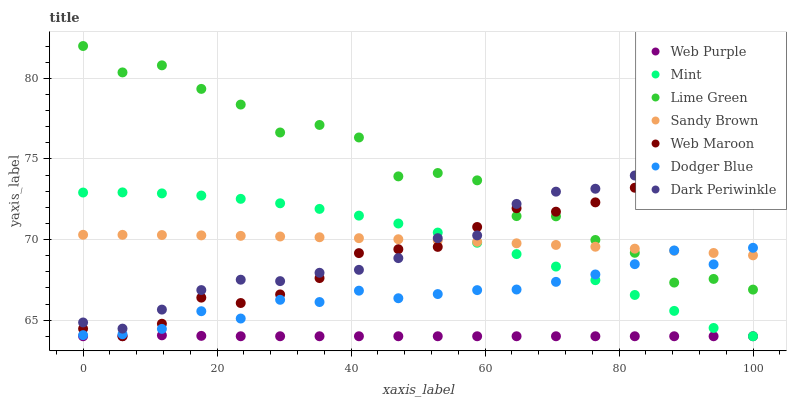Does Web Purple have the minimum area under the curve?
Answer yes or no. Yes. Does Lime Green have the maximum area under the curve?
Answer yes or no. Yes. Does Mint have the minimum area under the curve?
Answer yes or no. No. Does Mint have the maximum area under the curve?
Answer yes or no. No. Is Sandy Brown the smoothest?
Answer yes or no. Yes. Is Lime Green the roughest?
Answer yes or no. Yes. Is Mint the smoothest?
Answer yes or no. No. Is Mint the roughest?
Answer yes or no. No. Does Mint have the lowest value?
Answer yes or no. Yes. Does Dodger Blue have the lowest value?
Answer yes or no. No. Does Lime Green have the highest value?
Answer yes or no. Yes. Does Mint have the highest value?
Answer yes or no. No. Is Dodger Blue less than Dark Periwinkle?
Answer yes or no. Yes. Is Dark Periwinkle greater than Dodger Blue?
Answer yes or no. Yes. Does Web Maroon intersect Dodger Blue?
Answer yes or no. Yes. Is Web Maroon less than Dodger Blue?
Answer yes or no. No. Is Web Maroon greater than Dodger Blue?
Answer yes or no. No. Does Dodger Blue intersect Dark Periwinkle?
Answer yes or no. No. 